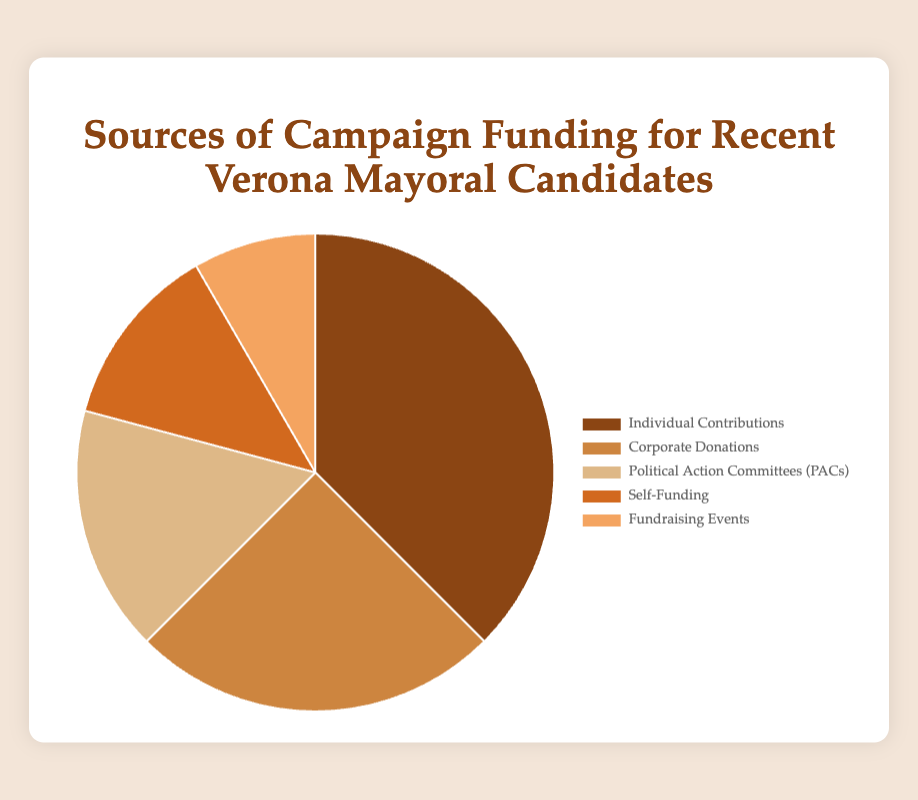What is the largest source of campaign funding according to the chart? The segment representing "Individual Contributions" is significantly larger than the others, indicating it is the largest source of campaign funding.
Answer: Individual Contributions Which funding source contributes the least to the campaign funding? The "Fundraising Events" segment is the smallest in the chart, which means it contributes the least.
Answer: Fundraising Events How much more is funded by Individual Contributions compared to Corporate Donations? The amount for Individual Contributions is €45,000 and for Corporate Donations is €30,000. The difference is €45,000 - €30,000 = €15,000.
Answer: €15,000 What percentage of the total funding comes from Corporate Donations? The total amount of all sources is €45,000 + €30,000 + €20,000 + €15,000 + €10,000 = €120,000. The percentage is (€30,000 / €120,000) * 100 = 25%.
Answer: 25% Are Politcal Action Committees (PACs) contributing more or less than Self-Funding? The chart shows that Political Action Committees (PACs) contribute €20,000 and Self-Funding contributes €15,000. €20,000 is more than €15,000.
Answer: More Which funding source has a medium share in percentage terms compared to others? There are five sources, so we order the amounts: Fundraising Events (€10,000), Self-Funding (€15,000), Political Action Committees (€20,000), Corporate Donations (€30,000), and Individual Contributions (€45,000). The medium one in this order is Political Action Committees (€20,000).
Answer: Political Action Committees (PACs) What is the total funding amount from non-individual sources? The non-individual sources are Corporate Donations (€30,000) + Political Action Committees (PACs) (€20,000) + Self-Funding (€15,000) + Fundraising Events (€10,000). The sum is €30,000 + €20,000 + €15,000 + €10,000 = €75,000.
Answer: €75,000 If the funding from Fundraising Events doubled, how would it compare to Self-Funding? Doubling the funding from Fundraising Events gives €10,000 * 2 = €20,000. Self-Funding is €15,000. After doubling, Fundraising Events (€20,000) would equal the current Political Action Committees funding and surpass Self-Funding (€15,000).
Answer: It would surpass Self-Funding Which funding source is represented by the darkest color in the pie chart? According to the visual description provided, the darkest color in the chart is associated with "Individual Contributions".
Answer: Individual Contributions 